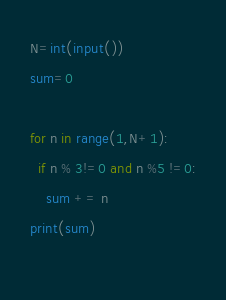<code> <loc_0><loc_0><loc_500><loc_500><_Python_>N=int(input())
sum=0

for n in range(1,N+1):
  if n % 3!=0 and n %5 !=0:
    sum += n
print(sum)
  </code> 